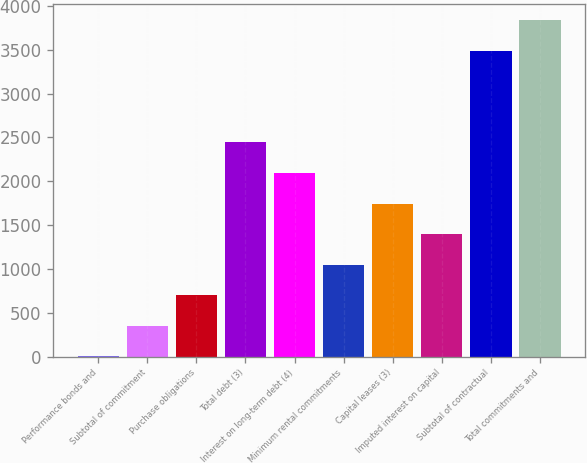Convert chart to OTSL. <chart><loc_0><loc_0><loc_500><loc_500><bar_chart><fcel>Performance bonds and<fcel>Subtotal of commitment<fcel>Purchase obligations<fcel>Total debt (3)<fcel>Interest on long-term debt (4)<fcel>Minimum rental commitments<fcel>Capital leases (3)<fcel>Imputed interest on capital<fcel>Subtotal of contractual<fcel>Total commitments and<nl><fcel>2<fcel>350.8<fcel>699.6<fcel>2443.6<fcel>2094.8<fcel>1048.4<fcel>1746<fcel>1397.2<fcel>3488<fcel>3836.8<nl></chart> 